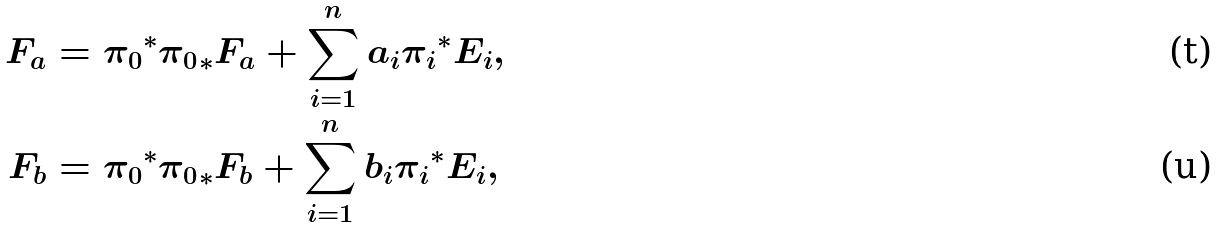<formula> <loc_0><loc_0><loc_500><loc_500>F _ { a } & = { \pi _ { 0 } } ^ { * } { \pi _ { 0 } } _ { * } F _ { a } + \sum _ { i = 1 } ^ { n } a _ { i } { \pi _ { i } } ^ { * } E _ { i } , \\ F _ { b } & = { \pi _ { 0 } } ^ { * } { \pi _ { 0 } } _ { * } F _ { b } + \sum _ { i = 1 } ^ { n } b _ { i } { \pi _ { i } } ^ { * } E _ { i } ,</formula> 